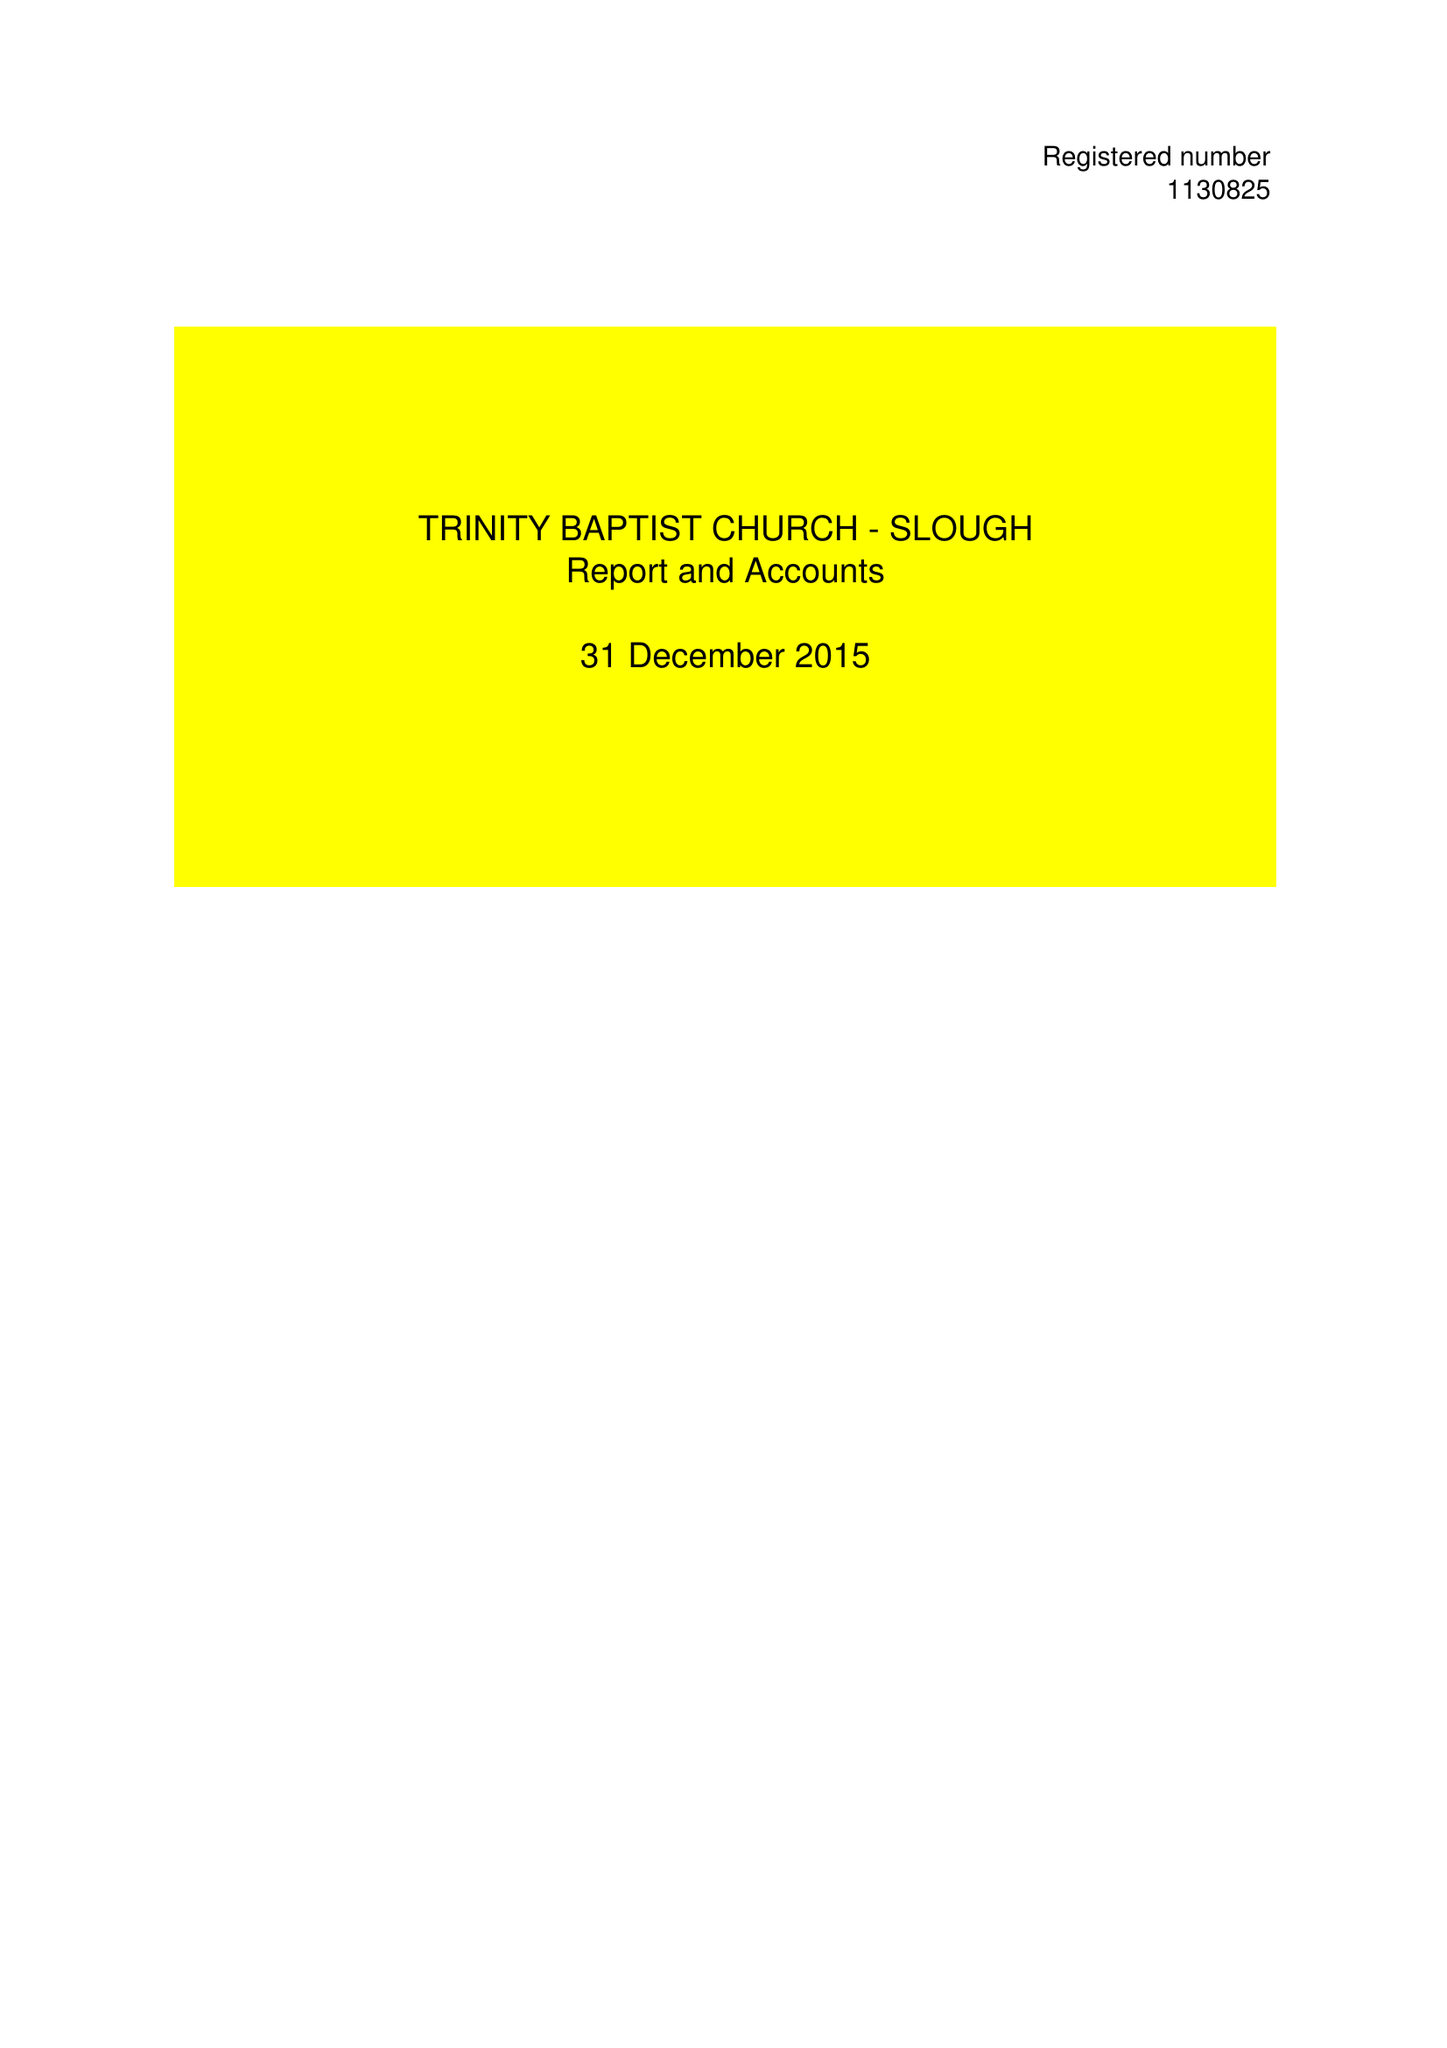What is the value for the income_annually_in_british_pounds?
Answer the question using a single word or phrase. 68005.00 